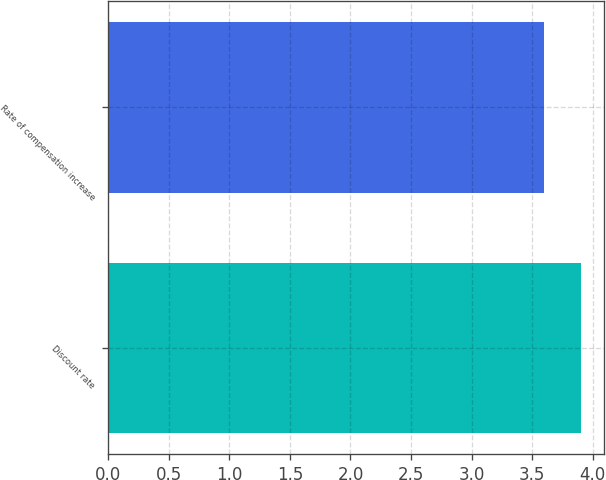Convert chart. <chart><loc_0><loc_0><loc_500><loc_500><bar_chart><fcel>Discount rate<fcel>Rate of compensation increase<nl><fcel>3.9<fcel>3.6<nl></chart> 